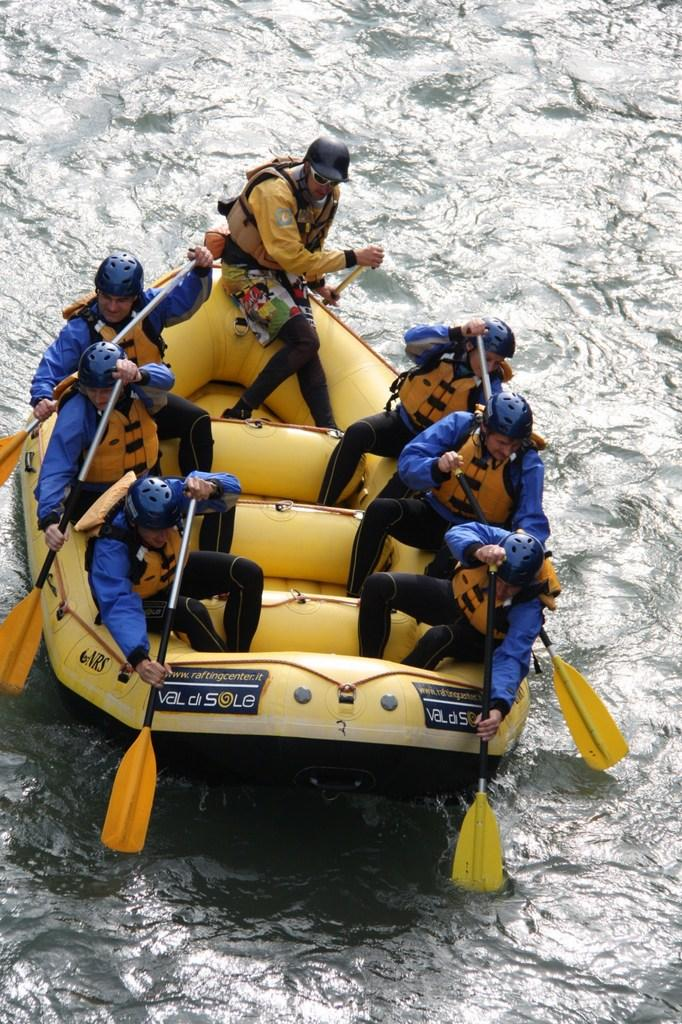How many people are in the image? There are seven persons in the image. What are the persons wearing in the image? The persons are wearing safe jackets in the image. What color is the boat in the image? The boat is yellow in color. What is visible at the bottom of the image? There is water visible at the bottom of the image. What protective gear are the persons wearing in the image? All persons are wearing helmets in the image. What type of thought can be seen emanating from the boat in the image? There are no thoughts visible in the image; it is a photograph of people wearing safe jackets and helmets on a yellow boat in the water. Can you tell me how many light bulbs are present in the image? There are no light bulbs present in the image; it features a boat with people on it in the water. 